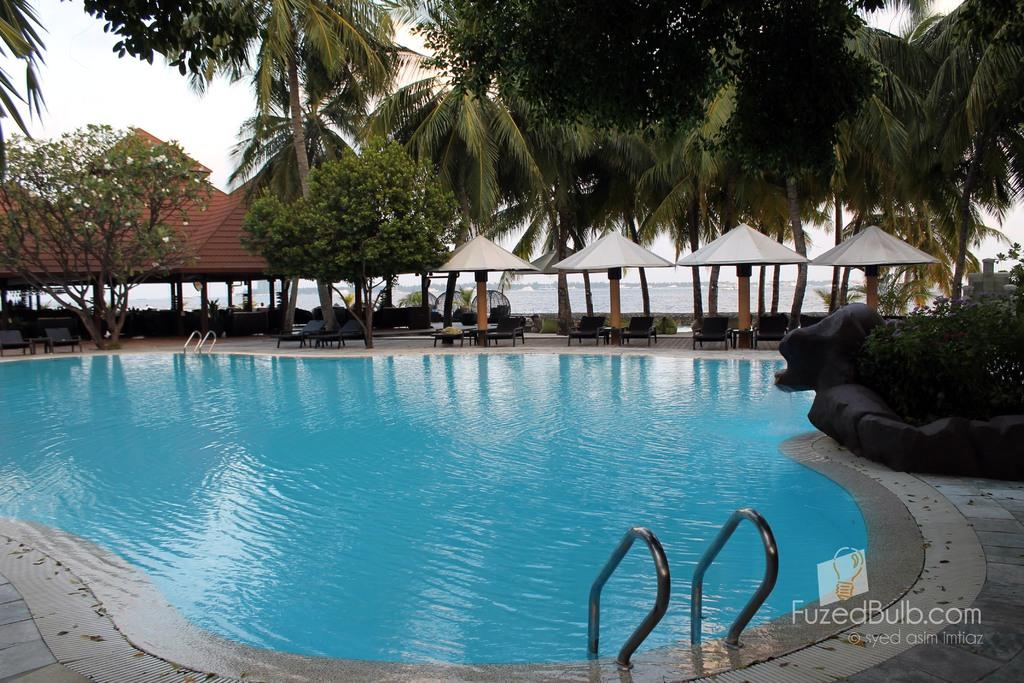What is the main feature in the foreground of the image? There is a swimming pool in the foreground of the image. What can be seen in the background of the image? In the background of the image, there are umbrellas, chairs, trees, a shed, and the sky. What might people use to provide shade while sitting in the chairs? The umbrellas in the background of the image might be used to provide shade while sitting in the chairs. What type of structure is located in the background of the image? There is a shed in the background of the image. What type of meal are the sisters eating near the swimming pool in the image? There are no sisters or meal present in the image; it only features a swimming pool, umbrellas, chairs, trees, a shed, and the sky. What type of animal can be seen interacting with the zebra near the shed in the image? There is no animal, including a zebra, present in the image; it only features a swimming pool, umbrellas, chairs, trees, a shed, and the sky. 